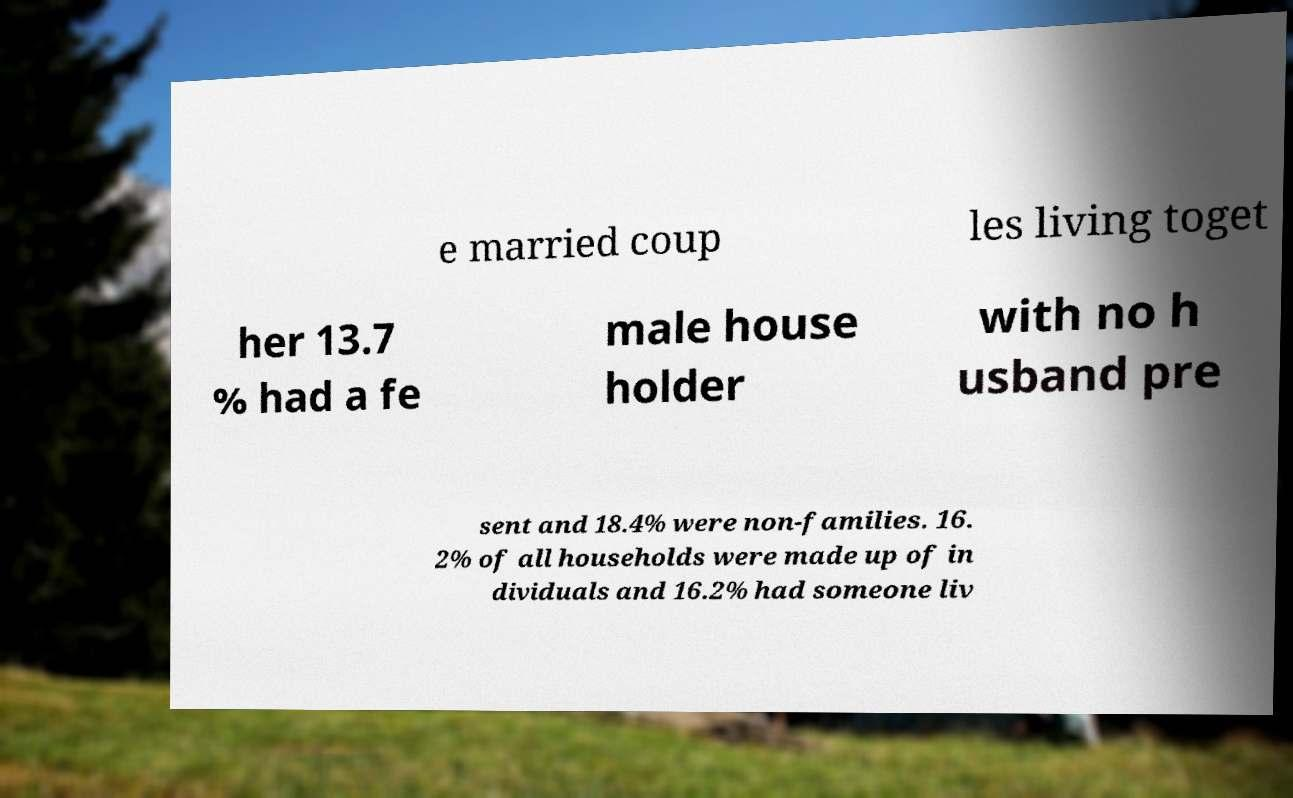Can you accurately transcribe the text from the provided image for me? e married coup les living toget her 13.7 % had a fe male house holder with no h usband pre sent and 18.4% were non-families. 16. 2% of all households were made up of in dividuals and 16.2% had someone liv 